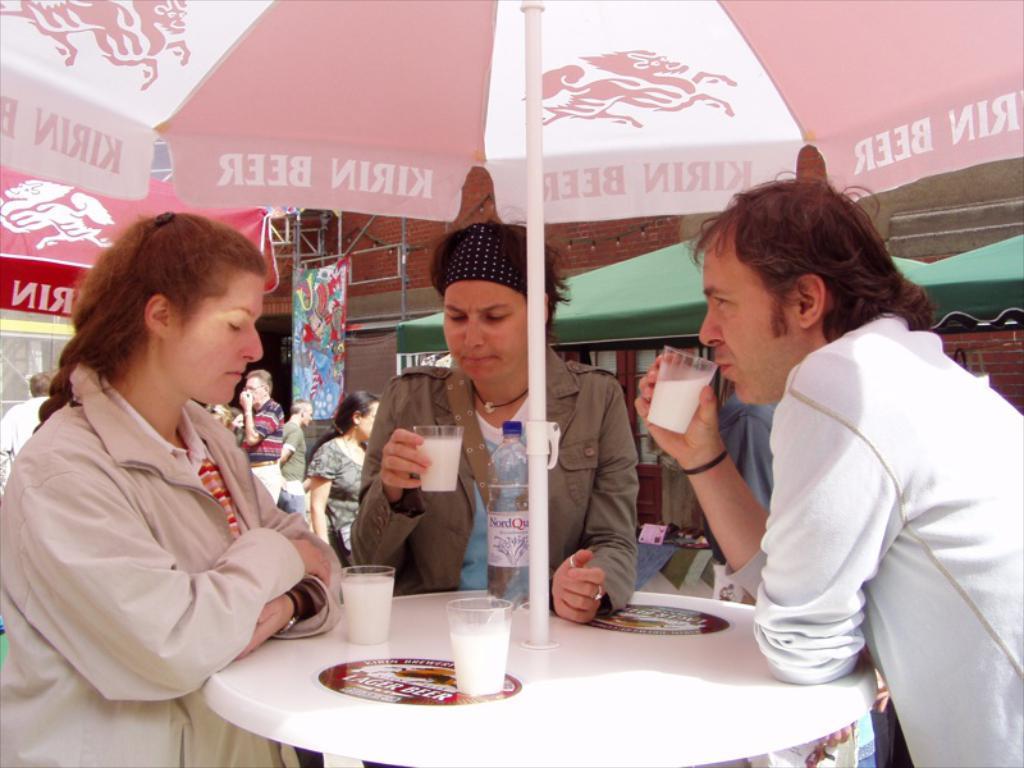How would you summarize this image in a sentence or two? Two women and a man are standing at a table with glasses of milk in their hand and on the table. 